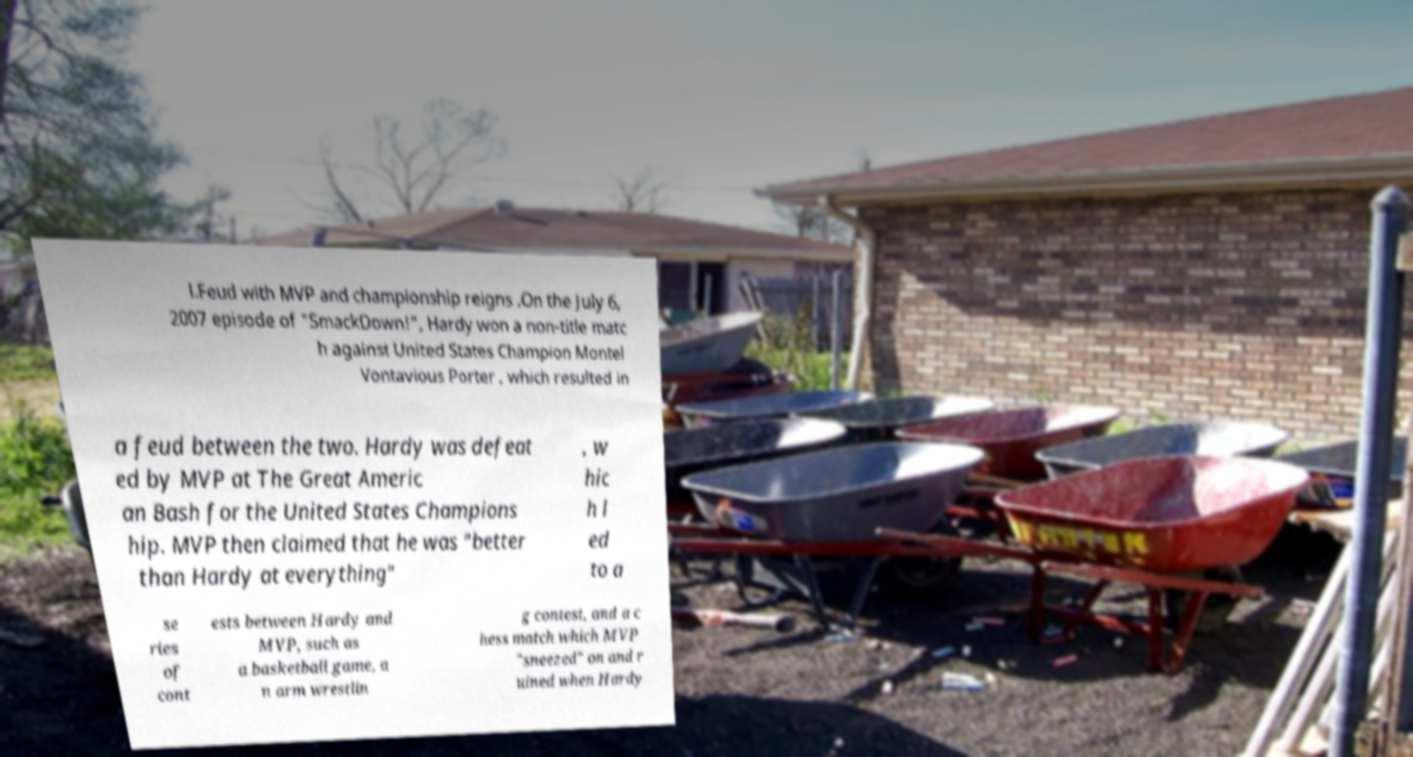There's text embedded in this image that I need extracted. Can you transcribe it verbatim? l.Feud with MVP and championship reigns .On the July 6, 2007 episode of "SmackDown!", Hardy won a non-title matc h against United States Champion Montel Vontavious Porter , which resulted in a feud between the two. Hardy was defeat ed by MVP at The Great Americ an Bash for the United States Champions hip. MVP then claimed that he was "better than Hardy at everything" , w hic h l ed to a se ries of cont ests between Hardy and MVP, such as a basketball game, a n arm wrestlin g contest, and a c hess match which MVP "sneezed" on and r uined when Hardy 